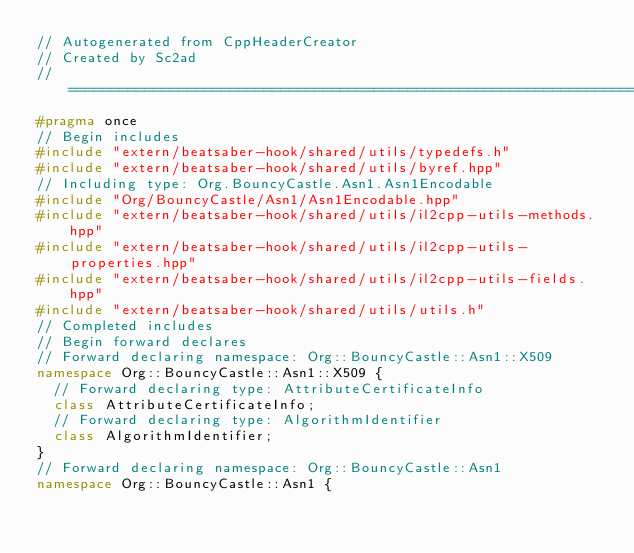Convert code to text. <code><loc_0><loc_0><loc_500><loc_500><_C++_>// Autogenerated from CppHeaderCreator
// Created by Sc2ad
// =========================================================================
#pragma once
// Begin includes
#include "extern/beatsaber-hook/shared/utils/typedefs.h"
#include "extern/beatsaber-hook/shared/utils/byref.hpp"
// Including type: Org.BouncyCastle.Asn1.Asn1Encodable
#include "Org/BouncyCastle/Asn1/Asn1Encodable.hpp"
#include "extern/beatsaber-hook/shared/utils/il2cpp-utils-methods.hpp"
#include "extern/beatsaber-hook/shared/utils/il2cpp-utils-properties.hpp"
#include "extern/beatsaber-hook/shared/utils/il2cpp-utils-fields.hpp"
#include "extern/beatsaber-hook/shared/utils/utils.h"
// Completed includes
// Begin forward declares
// Forward declaring namespace: Org::BouncyCastle::Asn1::X509
namespace Org::BouncyCastle::Asn1::X509 {
  // Forward declaring type: AttributeCertificateInfo
  class AttributeCertificateInfo;
  // Forward declaring type: AlgorithmIdentifier
  class AlgorithmIdentifier;
}
// Forward declaring namespace: Org::BouncyCastle::Asn1
namespace Org::BouncyCastle::Asn1 {</code> 